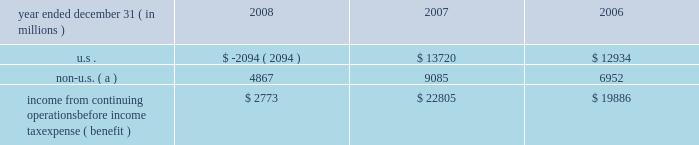Jpmorgan chase & co .
/ 2008 annual report 211 jpmorgan chase is subject to ongoing tax examinations by the tax authorities of the various jurisdictions in which it operates , including u.s .
Federal and state and non-u.s .
Jurisdictions .
The firm 2019s consoli- dated federal income tax returns are presently under examination by the internal revenue service ( 201cirs 201d ) for the years 2003 , 2004 and 2005 .
The consolidated federal income tax returns of bank one corporation , which merged with and into jpmorgan chase on july 1 , 2004 , are under examination for the years 2000 through 2003 , and for the period january 1 , 2004 , through july 1 , 2004 .
The consolidat- ed federal income tax returns of bear stearns for the years ended november 30 , 2003 , 2004 and 2005 , are also under examination .
All three examinations are expected to conclude in 2009 .
The irs audits of the consolidated federal income tax returns of jpmorgan chase for the years 2006 and 2007 , and for bear stearns for the years ended november 30 , 2006 and 2007 , are expected to commence in 2009 .
Administrative appeals are pending with the irs relating to prior examination periods .
For 2002 and prior years , refund claims relating to income and credit adjustments , and to tax attribute carry- backs , for jpmorgan chase and its predecessor entities , including bank one , have been filed .
Amended returns to reflect refund claims primarily attributable to net operating losses and tax credit carry- backs will be filed for the final bear stearns federal consolidated tax return for the period december 1 , 2007 , through may 30 , 2008 , and for prior years .
The table presents the u.s .
And non-u.s .
Components of income from continuing operations before income tax expense ( benefit ) . .
Non-u.s. ( a ) 4867 9085 6952 income from continuing operations before income tax expense ( benefit ) $ 2773 $ 22805 $ 19886 ( a ) for purposes of this table , non-u.s .
Income is defined as income generated from operations located outside the u.s .
Note 29 2013 restrictions on cash and intercom- pany funds transfers the business of jpmorgan chase bank , national association ( 201cjpmorgan chase bank , n.a . 201d ) is subject to examination and regula- tion by the office of the comptroller of the currency ( 201cocc 201d ) .
The bank is a member of the u.s .
Federal reserve system , and its deposits are insured by the fdic as discussed in note 20 on page 202 of this annual report .
The board of governors of the federal reserve system ( the 201cfederal reserve 201d ) requires depository institutions to maintain cash reserves with a federal reserve bank .
The average amount of reserve bal- ances deposited by the firm 2019s bank subsidiaries with various federal reserve banks was approximately $ 1.6 billion in 2008 and 2007 .
Restrictions imposed by u.s .
Federal law prohibit jpmorgan chase and certain of its affiliates from borrowing from banking subsidiaries unless the loans are secured in specified amounts .
Such secured loans to the firm or to other affiliates are generally limited to 10% ( 10 % ) of the banking subsidiary 2019s total capital , as determined by the risk- based capital guidelines ; the aggregate amount of all such loans is limited to 20% ( 20 % ) of the banking subsidiary 2019s total capital .
The principal sources of jpmorgan chase 2019s income ( on a parent com- pany 2013only basis ) are dividends and interest from jpmorgan chase bank , n.a. , and the other banking and nonbanking subsidiaries of jpmorgan chase .
In addition to dividend restrictions set forth in statutes and regulations , the federal reserve , the occ and the fdic have authority under the financial institutions supervisory act to pro- hibit or to limit the payment of dividends by the banking organizations they supervise , including jpmorgan chase and its subsidiaries that are banks or bank holding companies , if , in the banking regulator 2019s opin- ion , payment of a dividend would constitute an unsafe or unsound practice in light of the financial condition of the banking organization .
At january 1 , 2009 and 2008 , jpmorgan chase 2019s banking sub- sidiaries could pay , in the aggregate , $ 17.0 billion and $ 16.2 billion , respectively , in dividends to their respective bank holding companies without the prior approval of their relevant banking regulators .
The capacity to pay dividends in 2009 will be supplemented by the bank- ing subsidiaries 2019 earnings during the year .
In compliance with rules and regulations established by u.s .
And non-u.s .
Regulators , as of december 31 , 2008 and 2007 , cash in the amount of $ 20.8 billion and $ 16.0 billion , respectively , and securities with a fair value of $ 12.1 billion and $ 3.4 billion , respectively , were segregated in special bank accounts for the benefit of securities and futures brokerage customers. .
How many years are under exam for the firm or it's recent acquired subsidiaries? 
Computations: (2005 - 2000)
Answer: 5.0. 